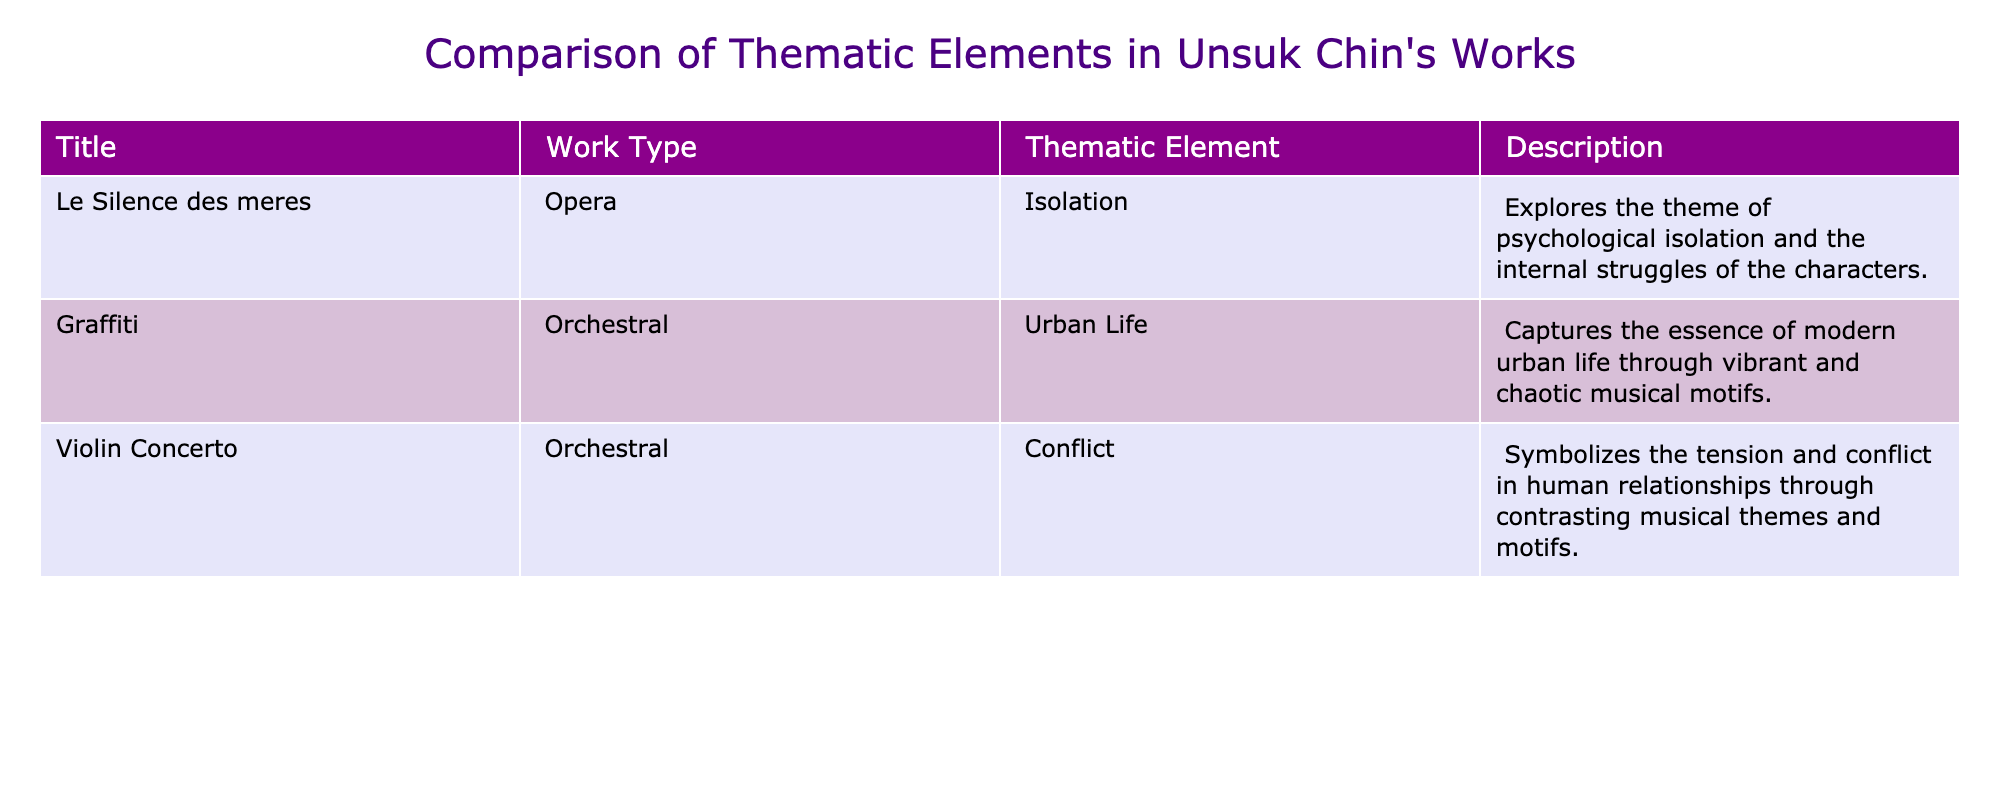What is the thematic element of "Le Silence des meres"? The thematic element is explicitly stated in the table as "Isolation." So, the answer is retrieved directly from the table.
Answer: Isolation How many works are categorized as orchestral? The table lists three works, out of which two are labeled as orchestral: "Graffiti" and "Violin Concerto." Thus, the count of orchestral works is 2.
Answer: 2 Does "Graffiti" explore conflict as a thematic element? In the table, the thematic element of "Graffiti" is "Urban Life," not conflict. Thus, the answer is no, indicating that "Graffiti" does not explore conflict.
Answer: No Which work depicts the theme of conflict, and what is its work type? The "Violin Concerto" is the work that depicts the theme of conflict, as seen from the table. The work type is "Orchestral." Therefore, both parts of the question are answered directly.
Answer: Violin Concerto, Orchestral What is the difference in thematic elements explored between "Le Silence des meres" and "Graffiti"? "Le Silence des meres" explores the theme of "Isolation," whereas "Graffiti" explores "Urban Life." To find the difference, we consider the unique thematic elements: Isolation and Urban Life are not the same, which establishes a fundamental difference. Therefore, they are distinct themes.
Answer: Distinct themes Are there more operas or orchestral works in the table? There is one opera ("Le Silence des meres") and two orchestral works ("Graffiti" and "Violin Concerto"). Since 2 (orchestral) is greater than 1 (opera), the answer is yes.
Answer: Yes Which thematic element is common between "Violin Concerto" and "Le Silence des meres"? The thematic elements are "Conflict" for "Violin Concerto" and "Isolation" for "Le Silence des meres." There are no common thematic elements between these two works, hence the answer is that there are none.
Answer: None What describes the nature of urban life in "Graffiti"? The description for "Graffiti" indicates it captures modern urban life through vibrant and chaotic musical motifs. Thus, this captures the essence of the thematic element well.
Answer: Vibrant and chaotic motifs Which work has a more personal thematic exploration: "Le Silence des meres" or "Violin Concerto"? "Le Silence des meres" with its theme of "Isolation" is more personal, focusing on psychological struggles, while "Violin Concerto" deals with conflict in relationships, which is more external. Hence, the nature of the theme indicates that "Le Silence des meres" has the more personal exploration.
Answer: Le Silence des meres 